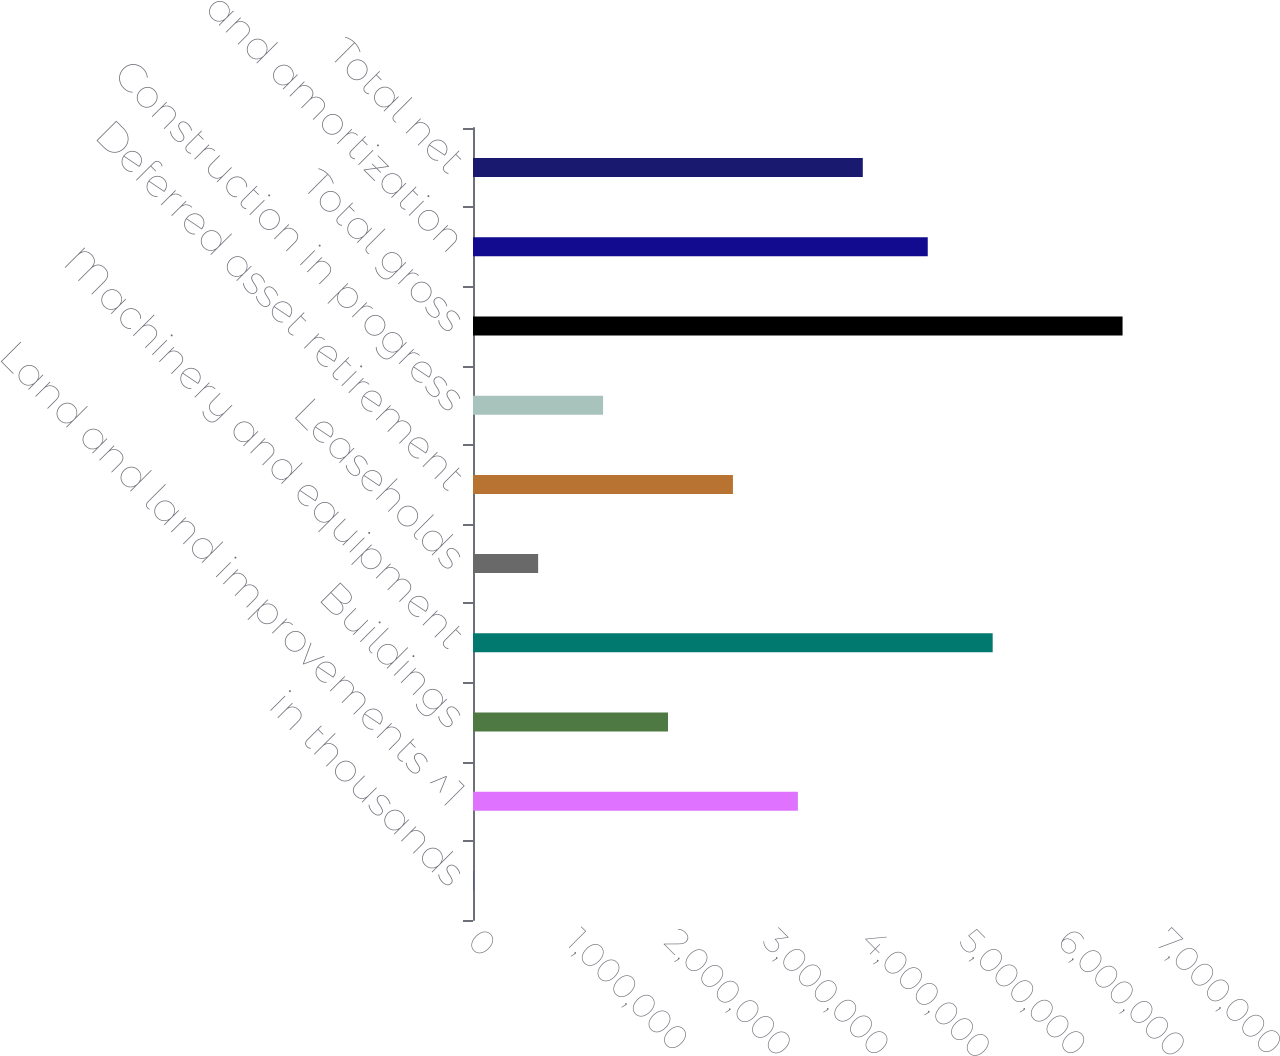Convert chart. <chart><loc_0><loc_0><loc_500><loc_500><bar_chart><fcel>in thousands<fcel>Land and land improvements ^1<fcel>Buildings<fcel>Machinery and equipment<fcel>Leaseholds<fcel>Deferred asset retirement<fcel>Construction in progress<fcel>Total gross<fcel>and amortization<fcel>Total net<nl><fcel>2014<fcel>3.30543e+06<fcel>1.98406e+06<fcel>5.28748e+06<fcel>662697<fcel>2.64475e+06<fcel>1.32338e+06<fcel>6.60884e+06<fcel>4.62679e+06<fcel>3.96611e+06<nl></chart> 